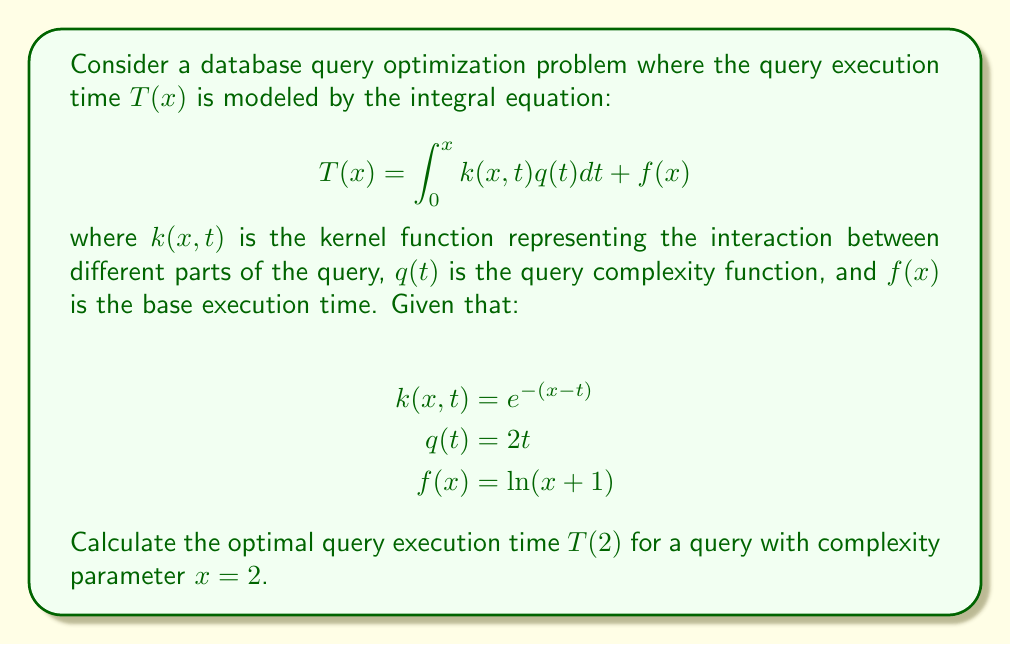Solve this math problem. To solve this problem, we need to follow these steps:

1) First, we need to substitute the given functions into the integral equation:

   $$T(2) = \int_0^2 e^{-(2-t)}(2t)dt + \ln(2+1)$$

2) Let's solve the integral part first:

   $$\int_0^2 e^{-(2-t)}(2t)dt = 2\int_0^2 te^{t-2}dt$$

3) We can solve this using integration by parts. Let $u = t$ and $dv = e^{t-2}dt$:

   $$2\left[te^{t-2}\Big|_0^2 - \int_0^2 e^{t-2}dt\right]$$

4) Evaluating this:

   $$2\left[(2e^0 - 0e^{-2}) - (e^0 - e^{-2})\right] = 2(2 - 1 + e^{-2}) = 2 + 2e^{-2}$$

5) Now, we add the $f(x)$ term:

   $$T(2) = 2 + 2e^{-2} + \ln(3)$$

6) This is our final result. We can simplify it slightly:

   $$T(2) = 2 + 2e^{-2} + \ln(3)$$
Answer: $2 + 2e^{-2} + \ln(3)$ 